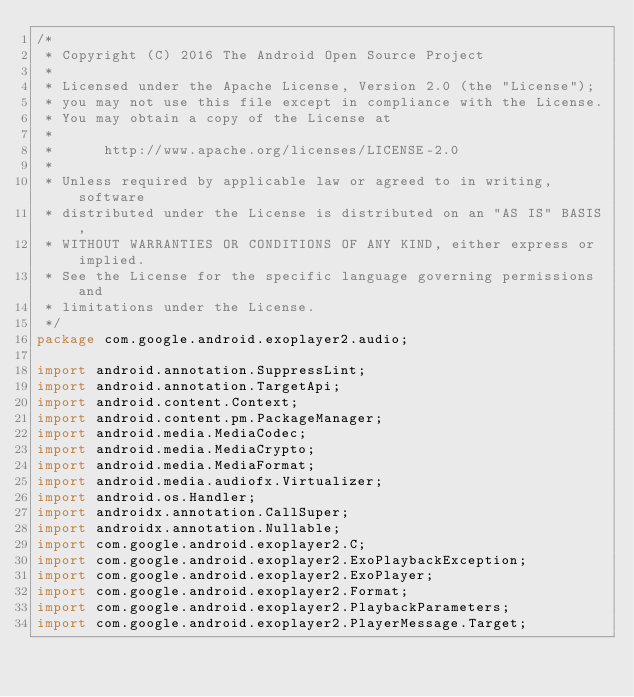<code> <loc_0><loc_0><loc_500><loc_500><_Java_>/*
 * Copyright (C) 2016 The Android Open Source Project
 *
 * Licensed under the Apache License, Version 2.0 (the "License");
 * you may not use this file except in compliance with the License.
 * You may obtain a copy of the License at
 *
 *      http://www.apache.org/licenses/LICENSE-2.0
 *
 * Unless required by applicable law or agreed to in writing, software
 * distributed under the License is distributed on an "AS IS" BASIS,
 * WITHOUT WARRANTIES OR CONDITIONS OF ANY KIND, either express or implied.
 * See the License for the specific language governing permissions and
 * limitations under the License.
 */
package com.google.android.exoplayer2.audio;

import android.annotation.SuppressLint;
import android.annotation.TargetApi;
import android.content.Context;
import android.content.pm.PackageManager;
import android.media.MediaCodec;
import android.media.MediaCrypto;
import android.media.MediaFormat;
import android.media.audiofx.Virtualizer;
import android.os.Handler;
import androidx.annotation.CallSuper;
import androidx.annotation.Nullable;
import com.google.android.exoplayer2.C;
import com.google.android.exoplayer2.ExoPlaybackException;
import com.google.android.exoplayer2.ExoPlayer;
import com.google.android.exoplayer2.Format;
import com.google.android.exoplayer2.PlaybackParameters;
import com.google.android.exoplayer2.PlayerMessage.Target;</code> 